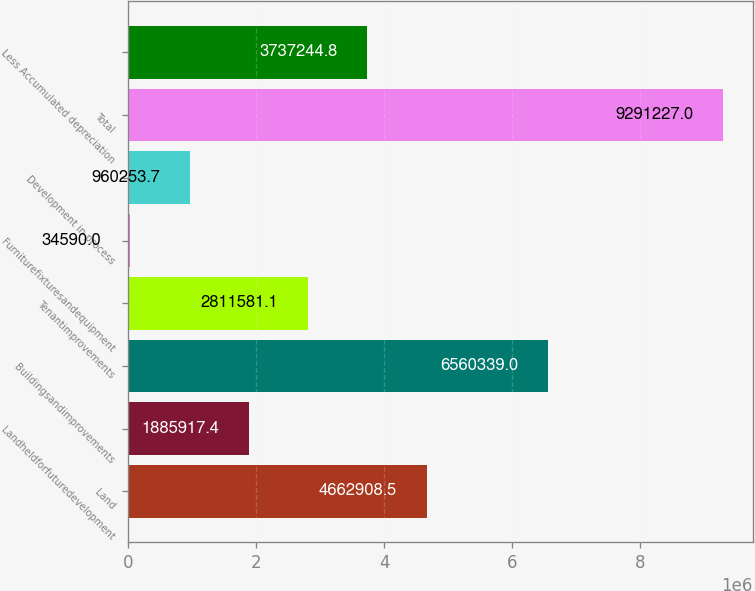Convert chart. <chart><loc_0><loc_0><loc_500><loc_500><bar_chart><fcel>Land<fcel>Landheldforfuturedevelopment<fcel>Buildingsandimprovements<fcel>Tenantimprovements<fcel>Furniturefixturesandequipment<fcel>Development in process<fcel>Total<fcel>Less Accumulated depreciation<nl><fcel>4.66291e+06<fcel>1.88592e+06<fcel>6.56034e+06<fcel>2.81158e+06<fcel>34590<fcel>960254<fcel>9.29123e+06<fcel>3.73724e+06<nl></chart> 